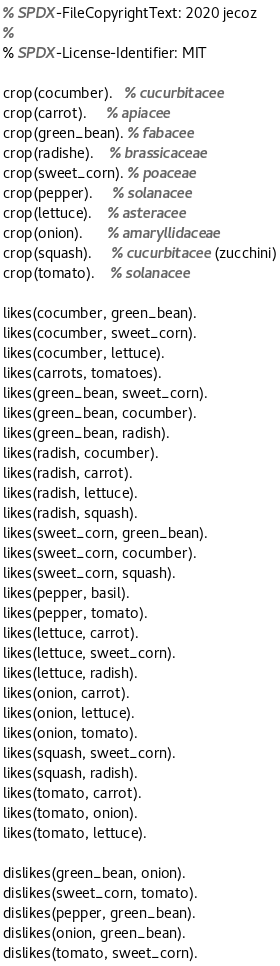Convert code to text. <code><loc_0><loc_0><loc_500><loc_500><_Perl_>% SPDX-FileCopyrightText: 2020 jecoz
%
% SPDX-License-Identifier: MIT

crop(cocumber).   % cucurbitacee
crop(carrot).     % apiacee
crop(green_bean). % fabacee
crop(radishe).    % brassicaceae
crop(sweet_corn). % poaceae
crop(pepper).     % solanacee
crop(lettuce).    % asteracee
crop(onion).      % amaryllidaceae
crop(squash).     % cucurbitacee (zucchini)
crop(tomato).    % solanacee

likes(cocumber, green_bean).
likes(cocumber, sweet_corn).
likes(cocumber, lettuce).
likes(carrots, tomatoes).
likes(green_bean, sweet_corn).
likes(green_bean, cocumber).
likes(green_bean, radish).
likes(radish, cocumber).
likes(radish, carrot).
likes(radish, lettuce).
likes(radish, squash).
likes(sweet_corn, green_bean).
likes(sweet_corn, cocumber).
likes(sweet_corn, squash).
likes(pepper, basil).
likes(pepper, tomato).
likes(lettuce, carrot).
likes(lettuce, sweet_corn).
likes(lettuce, radish).
likes(onion, carrot).
likes(onion, lettuce).
likes(onion, tomato).
likes(squash, sweet_corn).
likes(squash, radish).
likes(tomato, carrot).
likes(tomato, onion).
likes(tomato, lettuce).

dislikes(green_bean, onion).
dislikes(sweet_corn, tomato).
dislikes(pepper, green_bean).
dislikes(onion, green_bean).
dislikes(tomato, sweet_corn).
</code> 